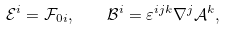<formula> <loc_0><loc_0><loc_500><loc_500>\mathcal { E } ^ { i } = \mathcal { F } _ { 0 i } , \quad \mathcal { B } ^ { i } = \varepsilon ^ { i j k } \nabla ^ { j } \mathcal { A } ^ { k } ,</formula> 